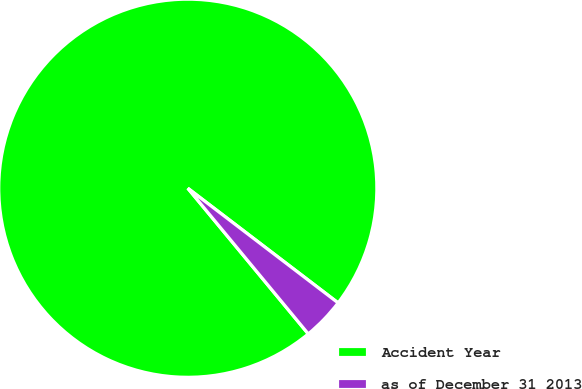<chart> <loc_0><loc_0><loc_500><loc_500><pie_chart><fcel>Accident Year<fcel>as of December 31 2013<nl><fcel>96.37%<fcel>3.63%<nl></chart> 